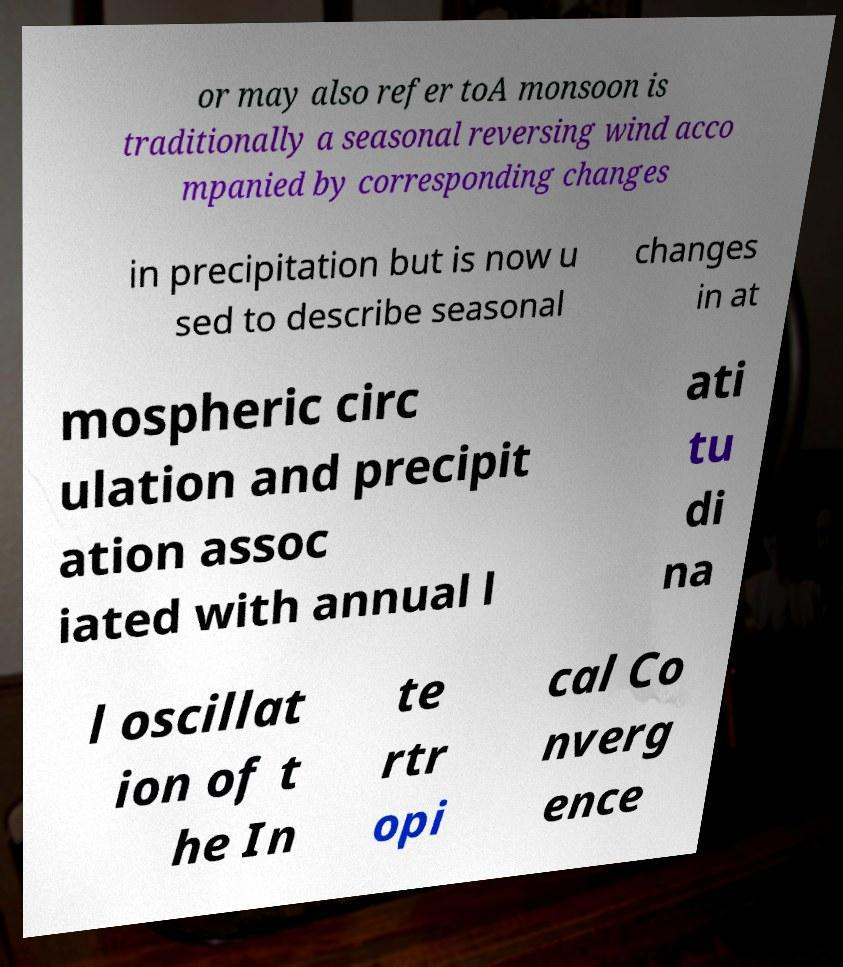Could you extract and type out the text from this image? or may also refer toA monsoon is traditionally a seasonal reversing wind acco mpanied by corresponding changes in precipitation but is now u sed to describe seasonal changes in at mospheric circ ulation and precipit ation assoc iated with annual l ati tu di na l oscillat ion of t he In te rtr opi cal Co nverg ence 